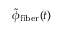<formula> <loc_0><loc_0><loc_500><loc_500>\tilde { \phi } _ { f i b e r } ( t )</formula> 